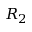Convert formula to latex. <formula><loc_0><loc_0><loc_500><loc_500>R _ { 2 }</formula> 